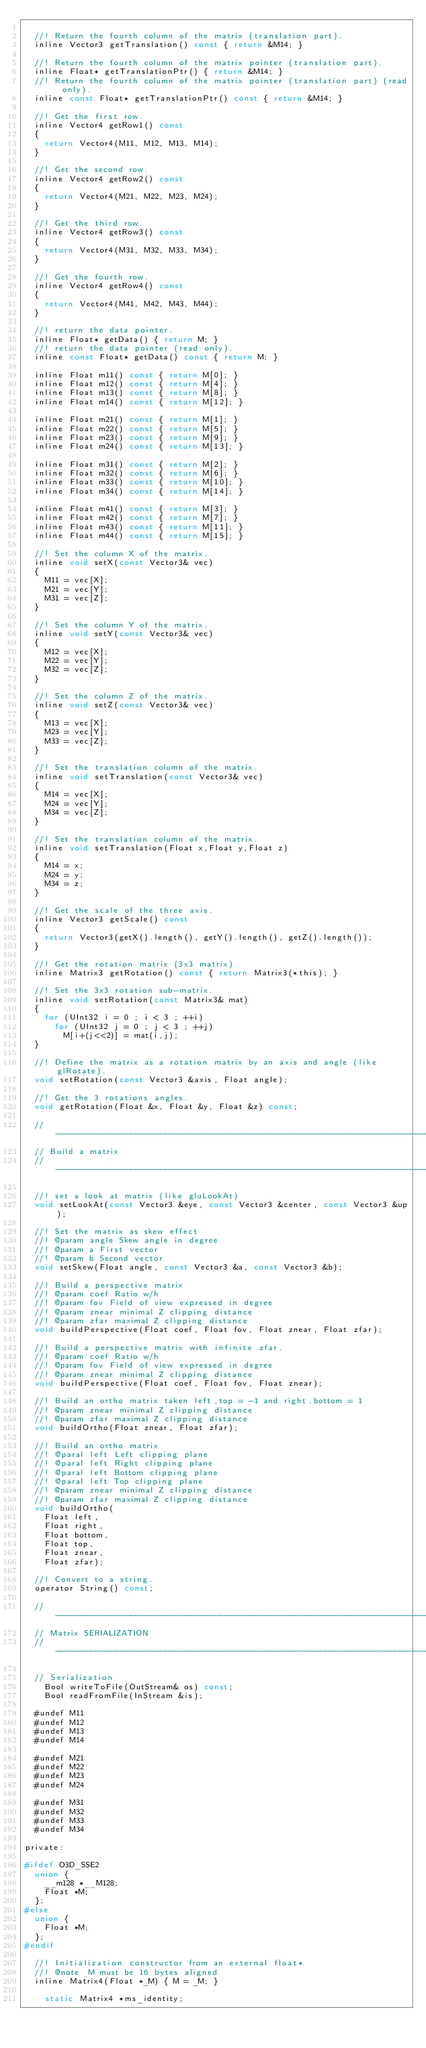Convert code to text. <code><loc_0><loc_0><loc_500><loc_500><_C_>
	//! Return the fourth column of the matrix (translation part).
	inline Vector3 getTranslation() const { return &M14; }

	//! Return the fourth column of the matrix pointer (translation part).
	inline Float* getTranslationPtr() { return &M14; }
	//! Return the fourth column of the matrix pointer (translation part) (read only).
	inline const Float* getTranslationPtr() const { return &M14; }

	//! Get the first row.
	inline Vector4 getRow1() const
	{
		return Vector4(M11, M12, M13, M14);
	}

	//! Get the second row.
	inline Vector4 getRow2() const
	{
		return Vector4(M21, M22, M23, M24);
	}

	//! Get the third row.
	inline Vector4 getRow3() const
	{
		return Vector4(M31, M32, M33, M34);
	}

	//! Get the fourth row.
	inline Vector4 getRow4() const
	{
		return Vector4(M41, M42, M43, M44);
	}

	//! return the data pointer.
	inline Float* getData() { return M; }
	//! return the data pointer (read only).
	inline const Float* getData() const { return M; }

	inline Float m11() const { return M[0]; }
	inline Float m12() const { return M[4]; }
	inline Float m13() const { return M[8]; }
	inline Float m14() const { return M[12]; }

	inline Float m21() const { return M[1]; }
	inline Float m22() const { return M[5]; }
	inline Float m23() const { return M[9]; }
	inline Float m24() const { return M[13]; }

	inline Float m31() const { return M[2]; }
	inline Float m32() const { return M[6]; }
	inline Float m33() const { return M[10]; }
	inline Float m34() const { return M[14]; }

	inline Float m41() const { return M[3]; }
	inline Float m42() const { return M[7]; }
	inline Float m43() const { return M[11]; }
	inline Float m44() const { return M[15]; }

	//! Set the column X of the matrix.
	inline void setX(const Vector3& vec)
	{
		M11 = vec[X];
		M21 = vec[Y];
		M31 = vec[Z];
	}

	//! Set the column Y of the matrix.
	inline void setY(const Vector3& vec)
	{
		M12 = vec[X];
		M22 = vec[Y];
		M32 = vec[Z];
	}

	//! Set the column Z of the matrix.
	inline void setZ(const Vector3& vec)
	{
		M13 = vec[X];
		M23 = vec[Y];
		M33 = vec[Z];
	}

	//! Set the translation column of the matrix.
	inline void setTranslation(const Vector3& vec)
	{
		M14 = vec[X];
		M24 = vec[Y];
		M34 = vec[Z];
	}

	//! Set the translation column of the matrix.
	inline void setTranslation(Float x,Float y,Float z)
	{
		M14 = x;
		M24 = y;
		M34 = z;
	}

	//! Get the scale of the three axis.
	inline Vector3 getScale() const
	{
		return Vector3(getX().length(), getY().length(), getZ().length());
	}

	//! Get the rotation matrix (3x3 matrix).
	inline Matrix3 getRotation() const { return Matrix3(*this); }

	//! Set the 3x3 rotation sub-matrix.
	inline void setRotation(const Matrix3& mat)
	{
		for (UInt32 i = 0 ; i < 3 ; ++i)
			for (UInt32 j = 0 ; j < 3 ; ++j)
				M[i+(j<<2)] = mat(i,j);
	}

	//! Define the matrix as a rotation matrix by an axis and angle (like glRotate).
	void setRotation(const Vector3 &axis, Float angle);

	//! Get the 3 rotations angles.
	void getRotation(Float &x, Float &y, Float &z) const;

	//-----------------------------------------------------------------------------------
	// Build a matrix
	//-----------------------------------------------------------------------------------

	//! set a look at matrix (like gluLookAt)
	void setLookAt(const Vector3 &eye, const Vector3 &center, const Vector3 &up);

	//! Set the matrix as skew effect
	//! @param angle Skew angle in degree
	//! @param a First vector
	//! @param b Second vector
	void setSkew(Float angle, const Vector3 &a, const Vector3 &b);

	//! Build a perspective matrix
	//! @param coef Ratio w/h
	//! @param fov Field of view expressed in degree
	//! @param znear minimal Z clipping distance
	//! @param zfar maximal Z clipping distance
	void buildPerspective(Float coef, Float fov, Float znear, Float zfar);

	//! Build a perspective matrix with infinite zfar.
	//! @param coef Ratio w/h
	//! @param fov Field of view expressed in degree
	//! @param znear minimal Z clipping distance
	void buildPerspective(Float coef, Float fov, Float znear);

	//! Build an ortho matrix taken left,top = -1 and right,bottom = 1
	//! @param znear minimal Z clipping distance
	//! @param zfar maximal Z clipping distance
	void buildOrtho(Float znear, Float zfar);

	//! Build an ortho matrix
	//! @paral left Left clipping plane
	//! @paral left Right clipping plane
	//! @paral left Bottom clipping plane
	//! @paral left Top clipping plane
	//! @param znear minimal Z clipping distance
	//! @param zfar maximal Z clipping distance
	void buildOrtho(
		Float left,
		Float right,
		Float bottom,
		Float top,
		Float znear,
		Float zfar);

	//! Convert to a string.
	operator String() const;

	//-----------------------------------------------------------------------------------
	// Matrix SERIALIZATION
	//-----------------------------------------------------------------------------------

	// Serialization
    Bool writeToFile(OutStream& os) const;
    Bool readFromFile(InStream &is);

	#undef M11
	#undef M12
	#undef M13
	#undef M14

	#undef M21
	#undef M22
	#undef M23
	#undef M24

	#undef M31
	#undef M32
	#undef M33
	#undef M34

private:

#ifdef O3D_SSE2
	union {
		__m128 *__M128;
		Float *M;
	};
#else
	union {
		Float *M;
	};
#endif

	//! Initialization constructor from an external float*
	//! @note _M must be 16 bytes aligned
	inline Matrix4(Float *_M) { M = _M; }

    static Matrix4 *ms_identity;</code> 